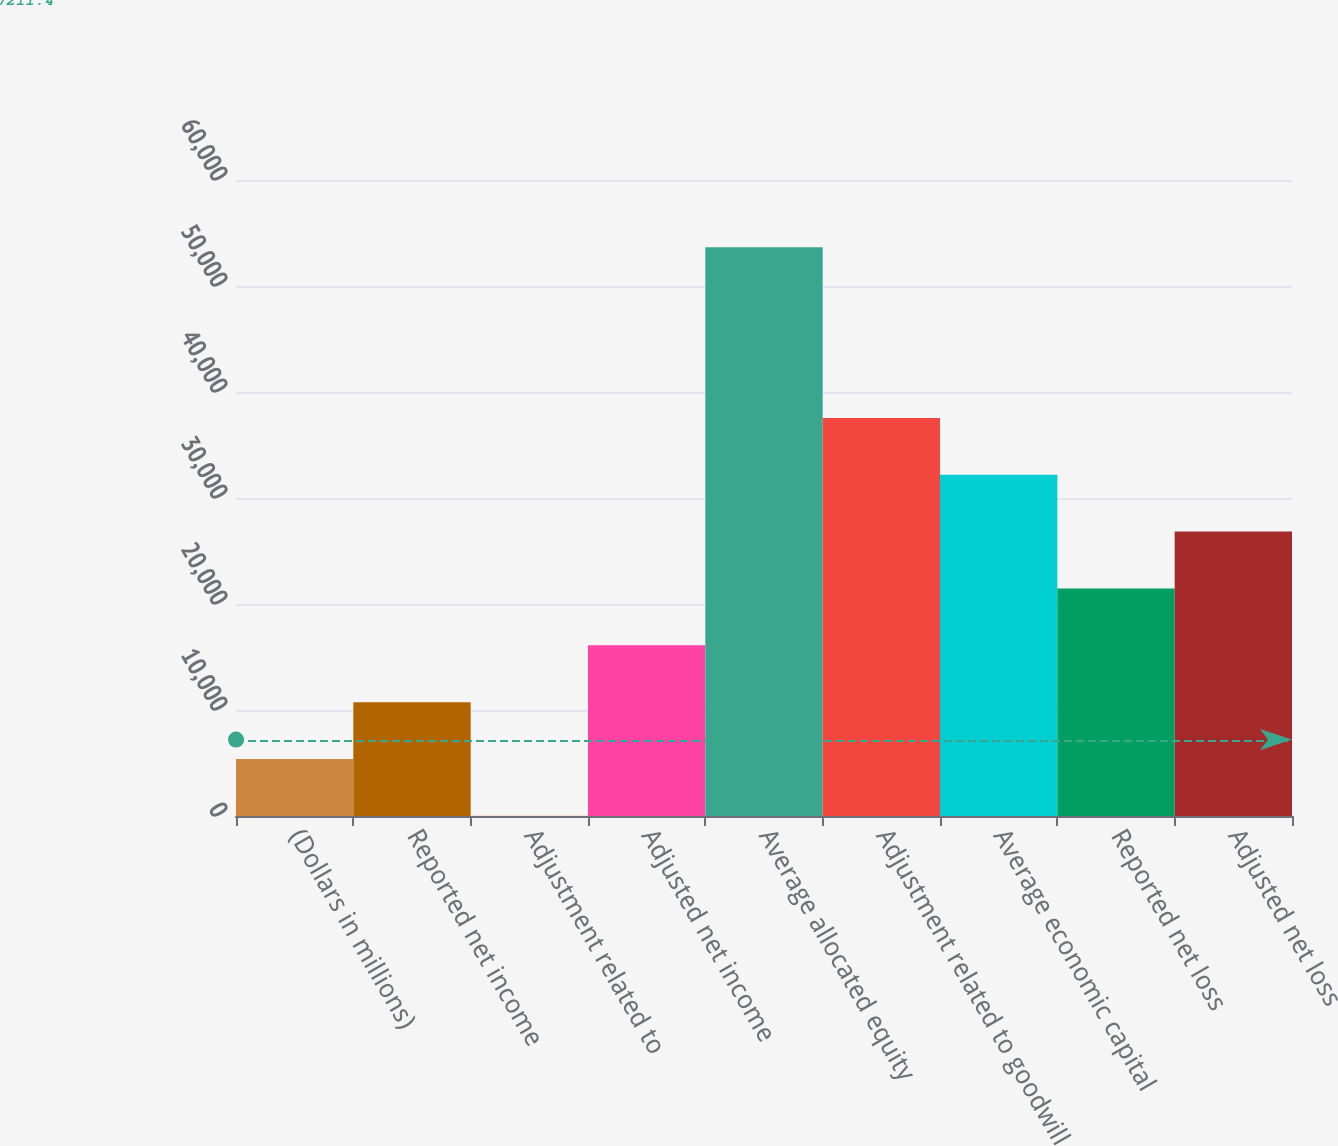Convert chart. <chart><loc_0><loc_0><loc_500><loc_500><bar_chart><fcel>(Dollars in millions)<fcel>Reported net income<fcel>Adjustment related to<fcel>Adjusted net income<fcel>Average allocated equity<fcel>Adjustment related to goodwill<fcel>Average economic capital<fcel>Reported net loss<fcel>Adjusted net loss<nl><fcel>5376.3<fcel>10739.6<fcel>13<fcel>16102.9<fcel>53646<fcel>37556.1<fcel>32192.8<fcel>21466.2<fcel>26829.5<nl></chart> 